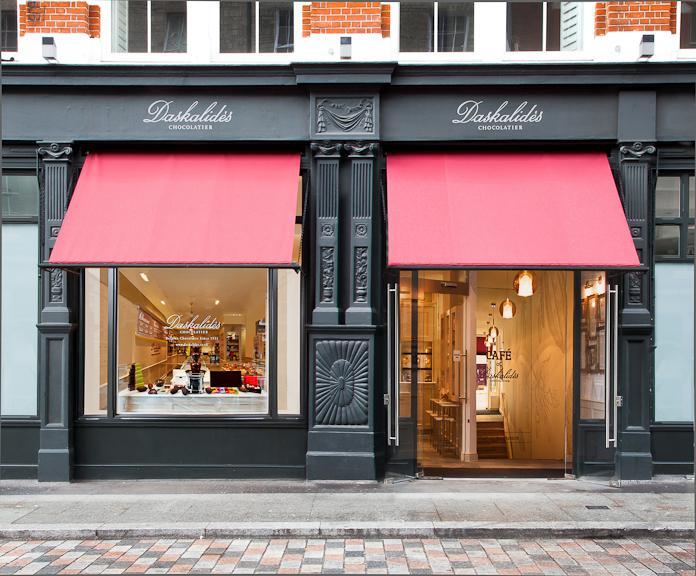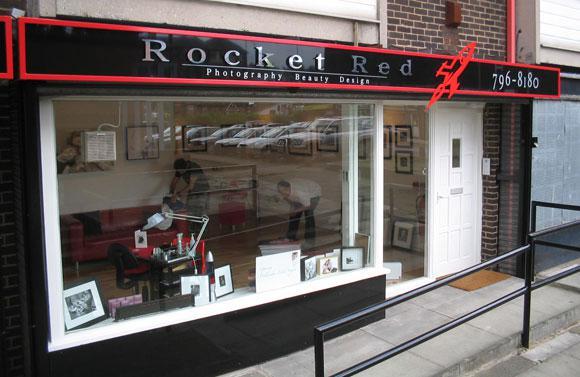The first image is the image on the left, the second image is the image on the right. For the images shown, is this caption "There is a striped awning in the image on the left." true? Answer yes or no. No. 